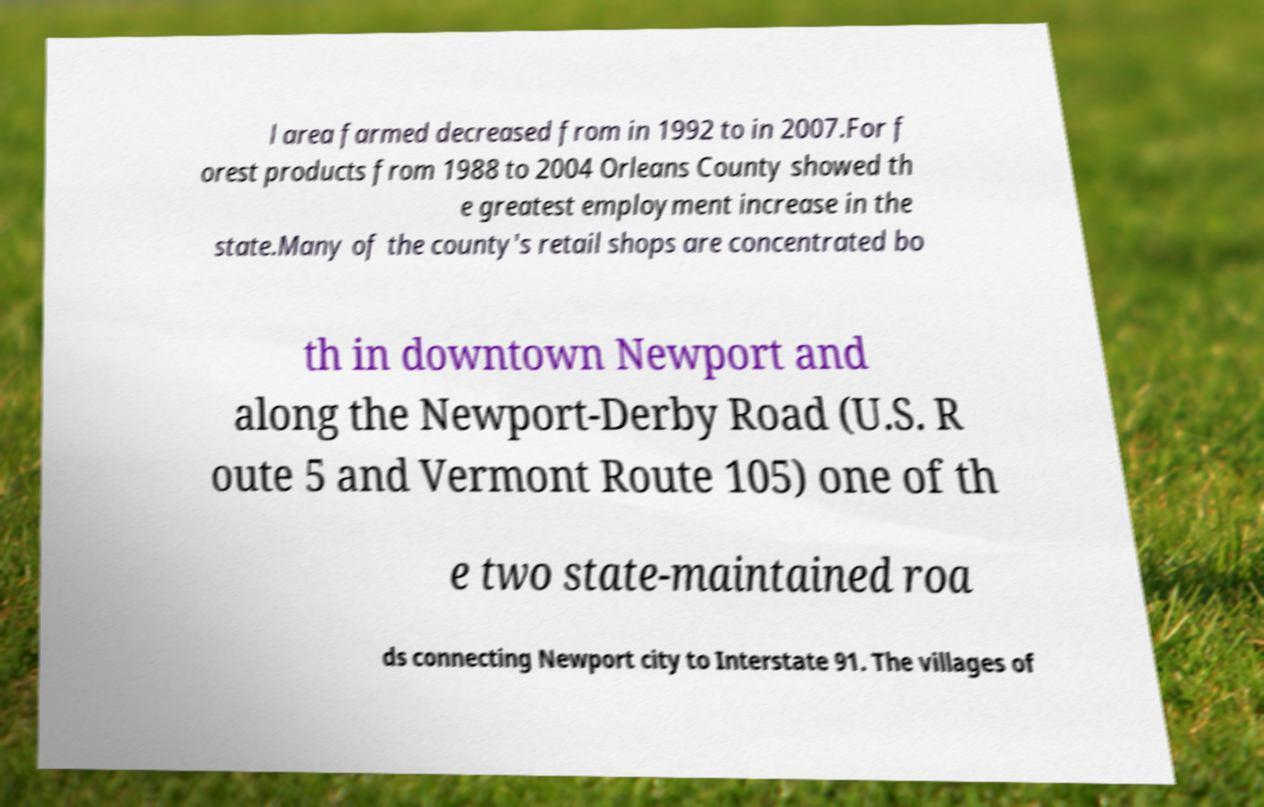What messages or text are displayed in this image? I need them in a readable, typed format. l area farmed decreased from in 1992 to in 2007.For f orest products from 1988 to 2004 Orleans County showed th e greatest employment increase in the state.Many of the county's retail shops are concentrated bo th in downtown Newport and along the Newport-Derby Road (U.S. R oute 5 and Vermont Route 105) one of th e two state-maintained roa ds connecting Newport city to Interstate 91. The villages of 